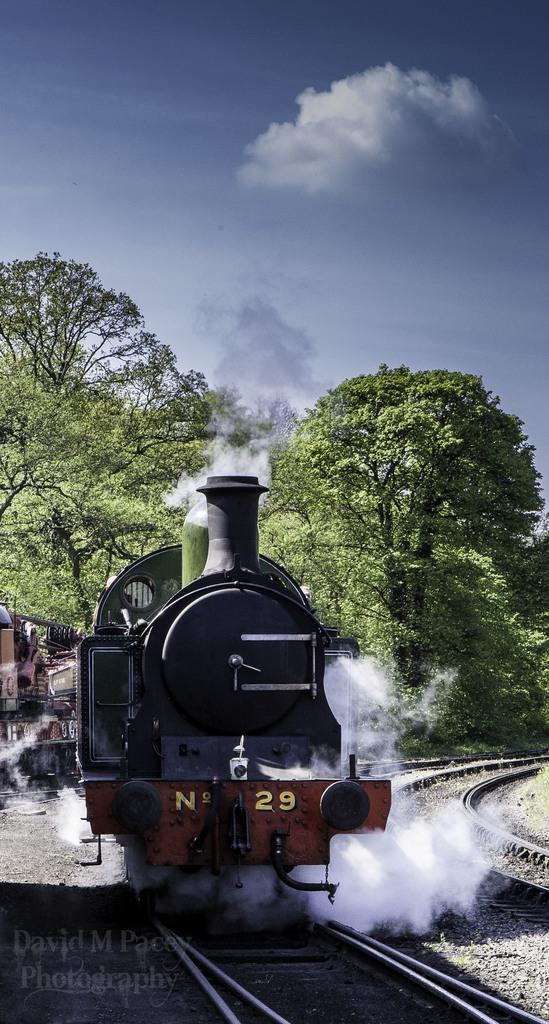What is the main subject of the image? The main subject of the image is a train. Where is the train located in the image? The train is on a railway track. What can be seen in the background of the image? There are trees and sky visible in the background of the image. Is there any text present in the image? Yes, there is some text at the bottom of the image. What type of cream can be seen on the train's wheels in the image? There is no cream visible on the train's wheels in the image. How deep are the roots of the trees visible in the background of the image? There is no information about the depth of the roots of the trees in the image, as we can only see the trees' trunks and leaves. 